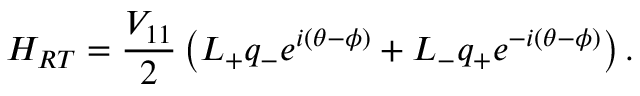<formula> <loc_0><loc_0><loc_500><loc_500>H _ { R T } = \frac { V _ { 1 1 } } { 2 } \left ( L _ { + } q _ { - } e ^ { i ( \theta - \phi ) } + L _ { - } q _ { + } e ^ { - i ( \theta - \phi ) } \right ) .</formula> 